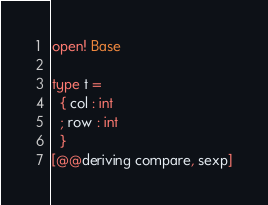<code> <loc_0><loc_0><loc_500><loc_500><_OCaml_>open! Base

type t =
  { col : int
  ; row : int
  }
[@@deriving compare, sexp]
</code> 